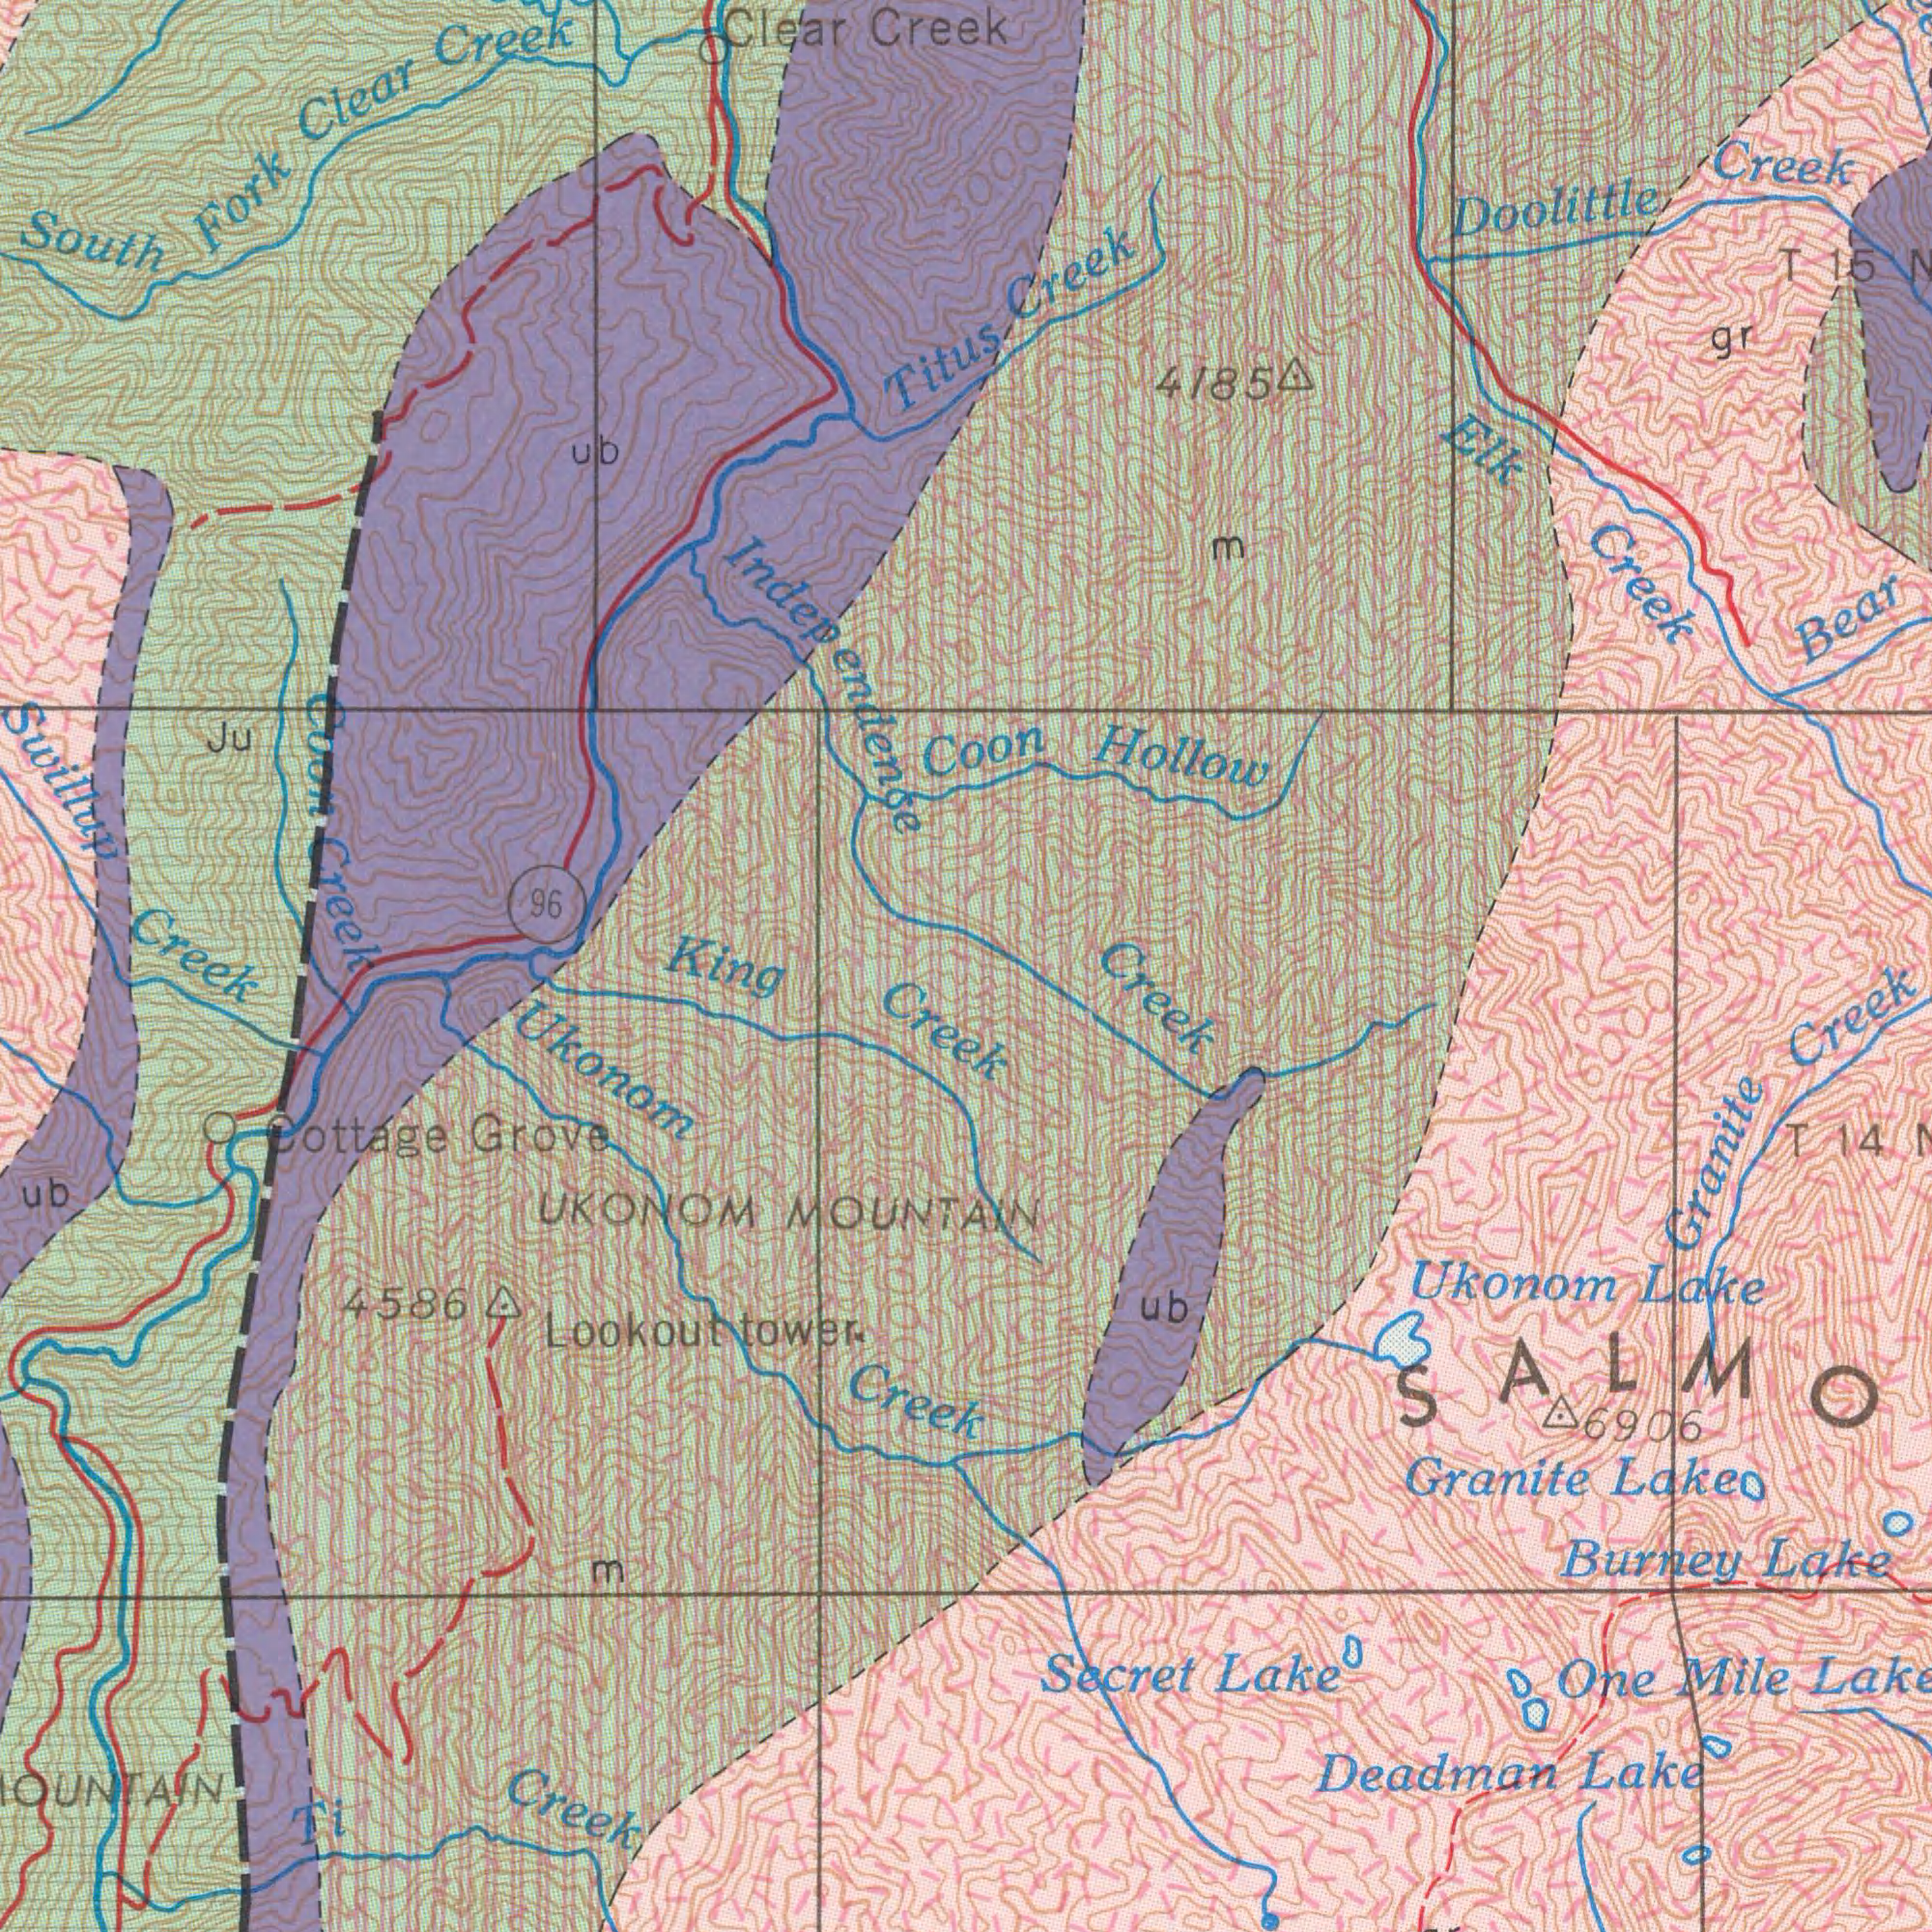What text can you see in the top-left section? South Fork Clear Creek Clear Creek 96 Titus Swillup Independence Ju Coon Creek ub What text appears in the bottom-left area of the image? Creek UKONOM MOUNTAIN Cottage Grove Ti Creek Ukonom Creek Lookout tower. King Creek ub 45864 M 3000 1000 3000 What text appears in the bottom-right area of the image? Creek Burney Lake Deadman Lake Secret Lake Ukonom Lake Granite Lake Granite Creek 6906 One Mile Lake ub SALMO T 14 6000 What text is shown in the top-right quadrant? Creek Doolittle Creek Elk Creek Bear 4185 Coon Hollow gr m T 15 N Creek 3000 